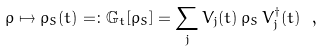Convert formula to latex. <formula><loc_0><loc_0><loc_500><loc_500>\rho \mapsto \rho _ { S } ( t ) = \colon \mathbb { G } _ { t } [ \rho _ { S } ] = \sum _ { j } V _ { j } ( t ) \, \rho _ { S } \, V ^ { \dagger } _ { j } ( t ) \ ,</formula> 